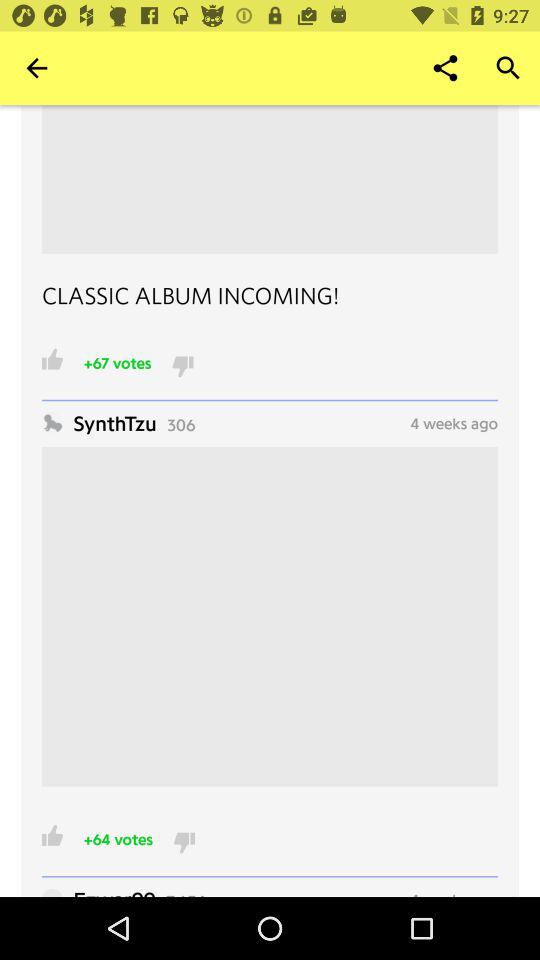How many people have voted for the post posted by "SynthTzu"? There are +64 people who have voted. 